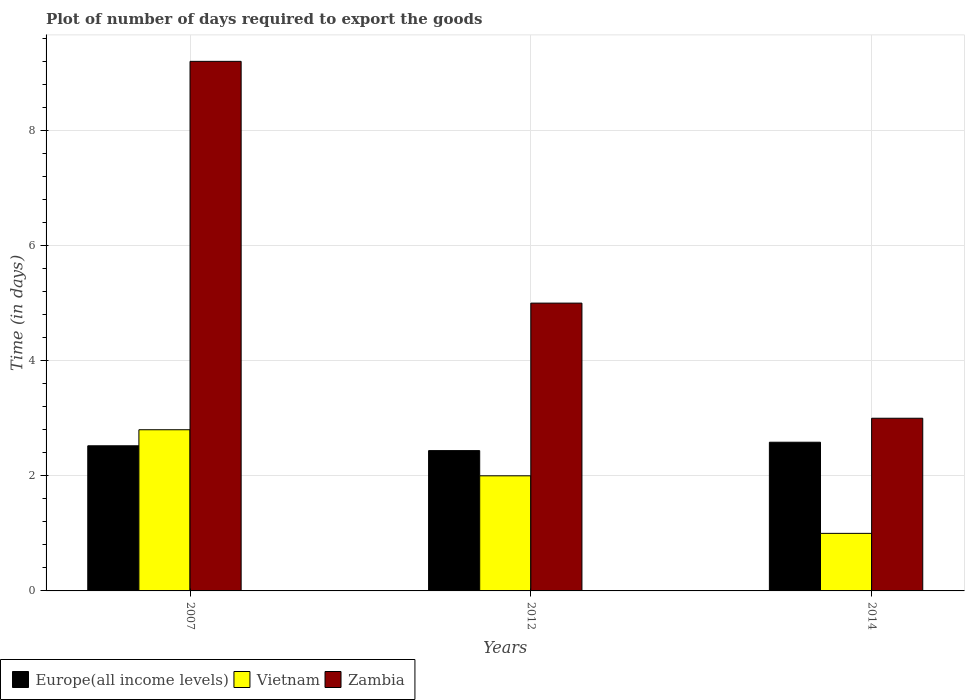Are the number of bars per tick equal to the number of legend labels?
Your response must be concise. Yes. Are the number of bars on each tick of the X-axis equal?
Keep it short and to the point. Yes. What is the label of the 3rd group of bars from the left?
Offer a very short reply. 2014. In which year was the time required to export goods in Europe(all income levels) maximum?
Offer a very short reply. 2014. What is the difference between the time required to export goods in Europe(all income levels) in 2007 and that in 2012?
Keep it short and to the point. 0.08. What is the difference between the time required to export goods in Zambia in 2007 and the time required to export goods in Europe(all income levels) in 2012?
Make the answer very short. 6.76. What is the average time required to export goods in Zambia per year?
Make the answer very short. 5.73. In the year 2012, what is the difference between the time required to export goods in Zambia and time required to export goods in Europe(all income levels)?
Provide a succinct answer. 2.56. In how many years, is the time required to export goods in Vietnam greater than 7.2 days?
Give a very brief answer. 0. What is the ratio of the time required to export goods in Zambia in 2007 to that in 2014?
Offer a terse response. 3.07. Is the time required to export goods in Europe(all income levels) in 2012 less than that in 2014?
Your answer should be very brief. Yes. What is the difference between the highest and the second highest time required to export goods in Vietnam?
Give a very brief answer. 0.8. What is the difference between the highest and the lowest time required to export goods in Zambia?
Give a very brief answer. 6.2. Is the sum of the time required to export goods in Europe(all income levels) in 2007 and 2012 greater than the maximum time required to export goods in Vietnam across all years?
Your answer should be compact. Yes. What does the 3rd bar from the left in 2007 represents?
Provide a short and direct response. Zambia. What does the 2nd bar from the right in 2014 represents?
Offer a very short reply. Vietnam. How many years are there in the graph?
Provide a short and direct response. 3. What is the difference between two consecutive major ticks on the Y-axis?
Provide a short and direct response. 2. Where does the legend appear in the graph?
Offer a terse response. Bottom left. How many legend labels are there?
Offer a very short reply. 3. What is the title of the graph?
Ensure brevity in your answer.  Plot of number of days required to export the goods. Does "Liechtenstein" appear as one of the legend labels in the graph?
Provide a succinct answer. No. What is the label or title of the X-axis?
Provide a succinct answer. Years. What is the label or title of the Y-axis?
Your response must be concise. Time (in days). What is the Time (in days) in Europe(all income levels) in 2007?
Give a very brief answer. 2.52. What is the Time (in days) of Zambia in 2007?
Make the answer very short. 9.2. What is the Time (in days) of Europe(all income levels) in 2012?
Offer a terse response. 2.44. What is the Time (in days) in Zambia in 2012?
Your response must be concise. 5. What is the Time (in days) of Europe(all income levels) in 2014?
Your answer should be very brief. 2.58. What is the Time (in days) of Zambia in 2014?
Your response must be concise. 3. Across all years, what is the maximum Time (in days) of Europe(all income levels)?
Ensure brevity in your answer.  2.58. Across all years, what is the maximum Time (in days) of Vietnam?
Make the answer very short. 2.8. Across all years, what is the maximum Time (in days) in Zambia?
Provide a short and direct response. 9.2. Across all years, what is the minimum Time (in days) in Europe(all income levels)?
Offer a terse response. 2.44. What is the total Time (in days) of Europe(all income levels) in the graph?
Your answer should be compact. 7.54. What is the total Time (in days) in Vietnam in the graph?
Give a very brief answer. 5.8. What is the difference between the Time (in days) in Europe(all income levels) in 2007 and that in 2012?
Keep it short and to the point. 0.08. What is the difference between the Time (in days) of Vietnam in 2007 and that in 2012?
Offer a very short reply. 0.8. What is the difference between the Time (in days) in Zambia in 2007 and that in 2012?
Ensure brevity in your answer.  4.2. What is the difference between the Time (in days) of Europe(all income levels) in 2007 and that in 2014?
Your response must be concise. -0.06. What is the difference between the Time (in days) of Vietnam in 2007 and that in 2014?
Your answer should be compact. 1.8. What is the difference between the Time (in days) of Zambia in 2007 and that in 2014?
Give a very brief answer. 6.2. What is the difference between the Time (in days) in Europe(all income levels) in 2012 and that in 2014?
Provide a short and direct response. -0.15. What is the difference between the Time (in days) in Zambia in 2012 and that in 2014?
Make the answer very short. 2. What is the difference between the Time (in days) in Europe(all income levels) in 2007 and the Time (in days) in Vietnam in 2012?
Offer a very short reply. 0.52. What is the difference between the Time (in days) of Europe(all income levels) in 2007 and the Time (in days) of Zambia in 2012?
Your answer should be compact. -2.48. What is the difference between the Time (in days) of Vietnam in 2007 and the Time (in days) of Zambia in 2012?
Your response must be concise. -2.2. What is the difference between the Time (in days) of Europe(all income levels) in 2007 and the Time (in days) of Vietnam in 2014?
Your answer should be very brief. 1.52. What is the difference between the Time (in days) of Europe(all income levels) in 2007 and the Time (in days) of Zambia in 2014?
Offer a very short reply. -0.48. What is the difference between the Time (in days) in Vietnam in 2007 and the Time (in days) in Zambia in 2014?
Keep it short and to the point. -0.2. What is the difference between the Time (in days) of Europe(all income levels) in 2012 and the Time (in days) of Vietnam in 2014?
Keep it short and to the point. 1.44. What is the difference between the Time (in days) in Europe(all income levels) in 2012 and the Time (in days) in Zambia in 2014?
Keep it short and to the point. -0.56. What is the difference between the Time (in days) in Vietnam in 2012 and the Time (in days) in Zambia in 2014?
Keep it short and to the point. -1. What is the average Time (in days) in Europe(all income levels) per year?
Give a very brief answer. 2.51. What is the average Time (in days) in Vietnam per year?
Offer a terse response. 1.93. What is the average Time (in days) of Zambia per year?
Keep it short and to the point. 5.73. In the year 2007, what is the difference between the Time (in days) in Europe(all income levels) and Time (in days) in Vietnam?
Keep it short and to the point. -0.28. In the year 2007, what is the difference between the Time (in days) in Europe(all income levels) and Time (in days) in Zambia?
Your answer should be very brief. -6.68. In the year 2007, what is the difference between the Time (in days) of Vietnam and Time (in days) of Zambia?
Provide a succinct answer. -6.4. In the year 2012, what is the difference between the Time (in days) in Europe(all income levels) and Time (in days) in Vietnam?
Your answer should be compact. 0.44. In the year 2012, what is the difference between the Time (in days) of Europe(all income levels) and Time (in days) of Zambia?
Make the answer very short. -2.56. In the year 2014, what is the difference between the Time (in days) of Europe(all income levels) and Time (in days) of Vietnam?
Keep it short and to the point. 1.58. In the year 2014, what is the difference between the Time (in days) of Europe(all income levels) and Time (in days) of Zambia?
Provide a short and direct response. -0.42. What is the ratio of the Time (in days) of Europe(all income levels) in 2007 to that in 2012?
Provide a short and direct response. 1.03. What is the ratio of the Time (in days) in Zambia in 2007 to that in 2012?
Offer a very short reply. 1.84. What is the ratio of the Time (in days) of Zambia in 2007 to that in 2014?
Ensure brevity in your answer.  3.07. What is the ratio of the Time (in days) in Europe(all income levels) in 2012 to that in 2014?
Keep it short and to the point. 0.94. What is the ratio of the Time (in days) of Vietnam in 2012 to that in 2014?
Keep it short and to the point. 2. What is the difference between the highest and the second highest Time (in days) in Europe(all income levels)?
Ensure brevity in your answer.  0.06. What is the difference between the highest and the second highest Time (in days) of Vietnam?
Ensure brevity in your answer.  0.8. What is the difference between the highest and the lowest Time (in days) in Europe(all income levels)?
Make the answer very short. 0.15. 